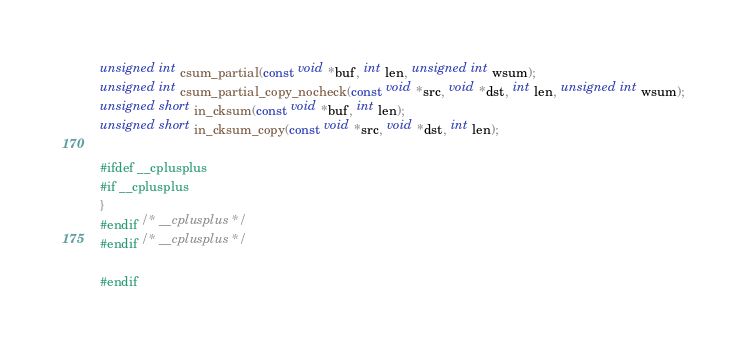Convert code to text. <code><loc_0><loc_0><loc_500><loc_500><_C_>
unsigned int csum_partial(const void *buf, int len, unsigned int wsum);
unsigned int csum_partial_copy_nocheck(const void *src, void *dst, int len, unsigned int wsum);
unsigned short in_cksum(const void *buf, int len);
unsigned short in_cksum_copy(const void *src, void *dst, int len);

#ifdef __cplusplus
#if __cplusplus
}
#endif /* __cplusplus */
#endif /* __cplusplus */

#endif
</code> 